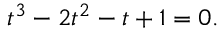Convert formula to latex. <formula><loc_0><loc_0><loc_500><loc_500>t ^ { 3 } - 2 t ^ { 2 } - t + 1 = 0 .</formula> 